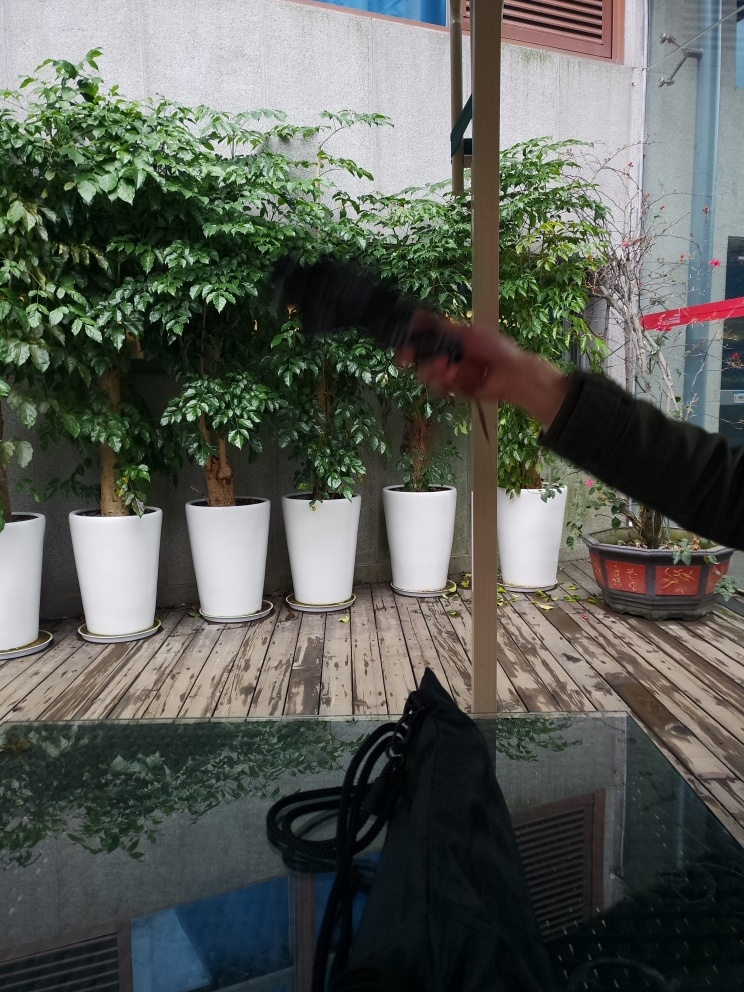How do the plants in this image contribute to the overall atmosphere of the setting? The plants contribute significantly to the serenity and freshness of the setting. Their vibrant green tones signify growth and bring a touch of nature to an otherwise urban environment. They also serve to soften the harsh lines of the surrounding architecture, creating an inviting space. 